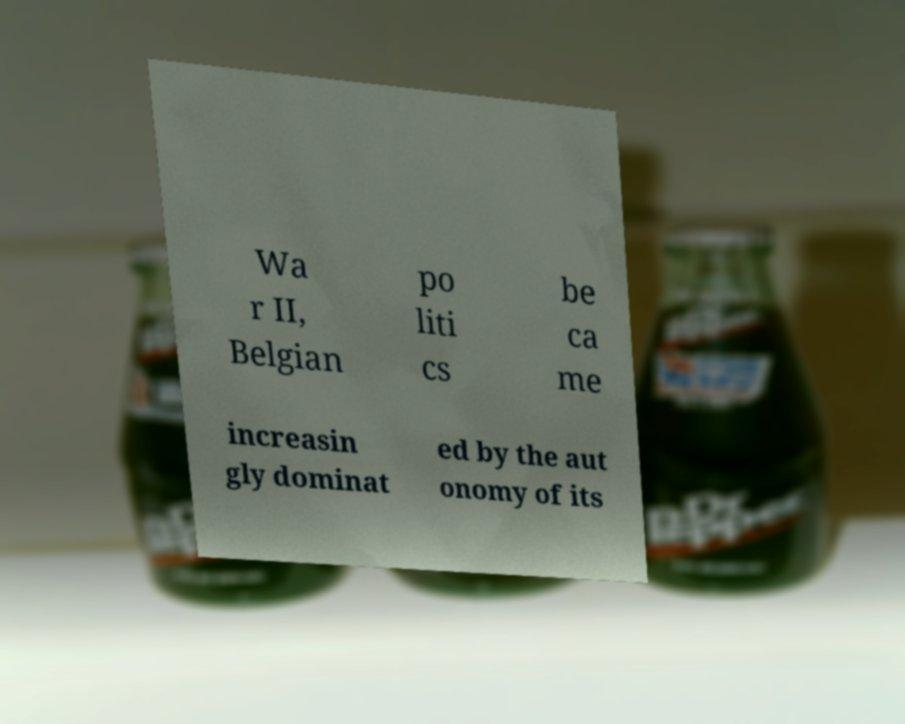For documentation purposes, I need the text within this image transcribed. Could you provide that? Wa r II, Belgian po liti cs be ca me increasin gly dominat ed by the aut onomy of its 